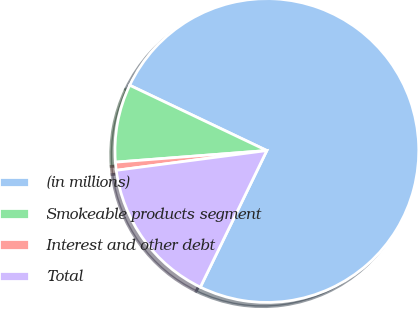Convert chart. <chart><loc_0><loc_0><loc_500><loc_500><pie_chart><fcel>(in millions)<fcel>Smokeable products segment<fcel>Interest and other debt<fcel>Total<nl><fcel>75.14%<fcel>8.29%<fcel>0.86%<fcel>15.71%<nl></chart> 